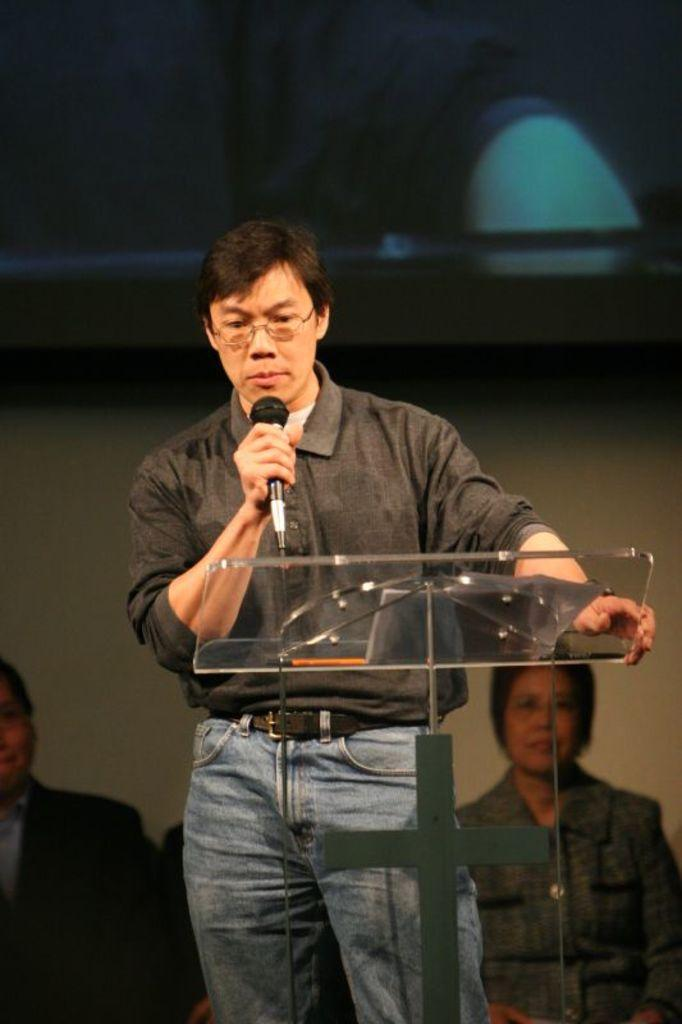What is the man in the image holding? The man is holding a microphone. Where is the man standing in the image? The man is standing in front of a podium. What is the man wearing on his upper body? The man is wearing a black shirt. What is the man wearing on his lower body? The man is wearing blue jeans. What accessory is the man wearing on his face? The man is wearing spectacles. Can you describe the people behind the man? There are people behind the man, but their specific features are not visible in the image. What type of boundary is visible in the image? There is no boundary visible in the image. What is the man's grandfather doing in the image? There is no mention of a grandfather in the image or the provided facts. 